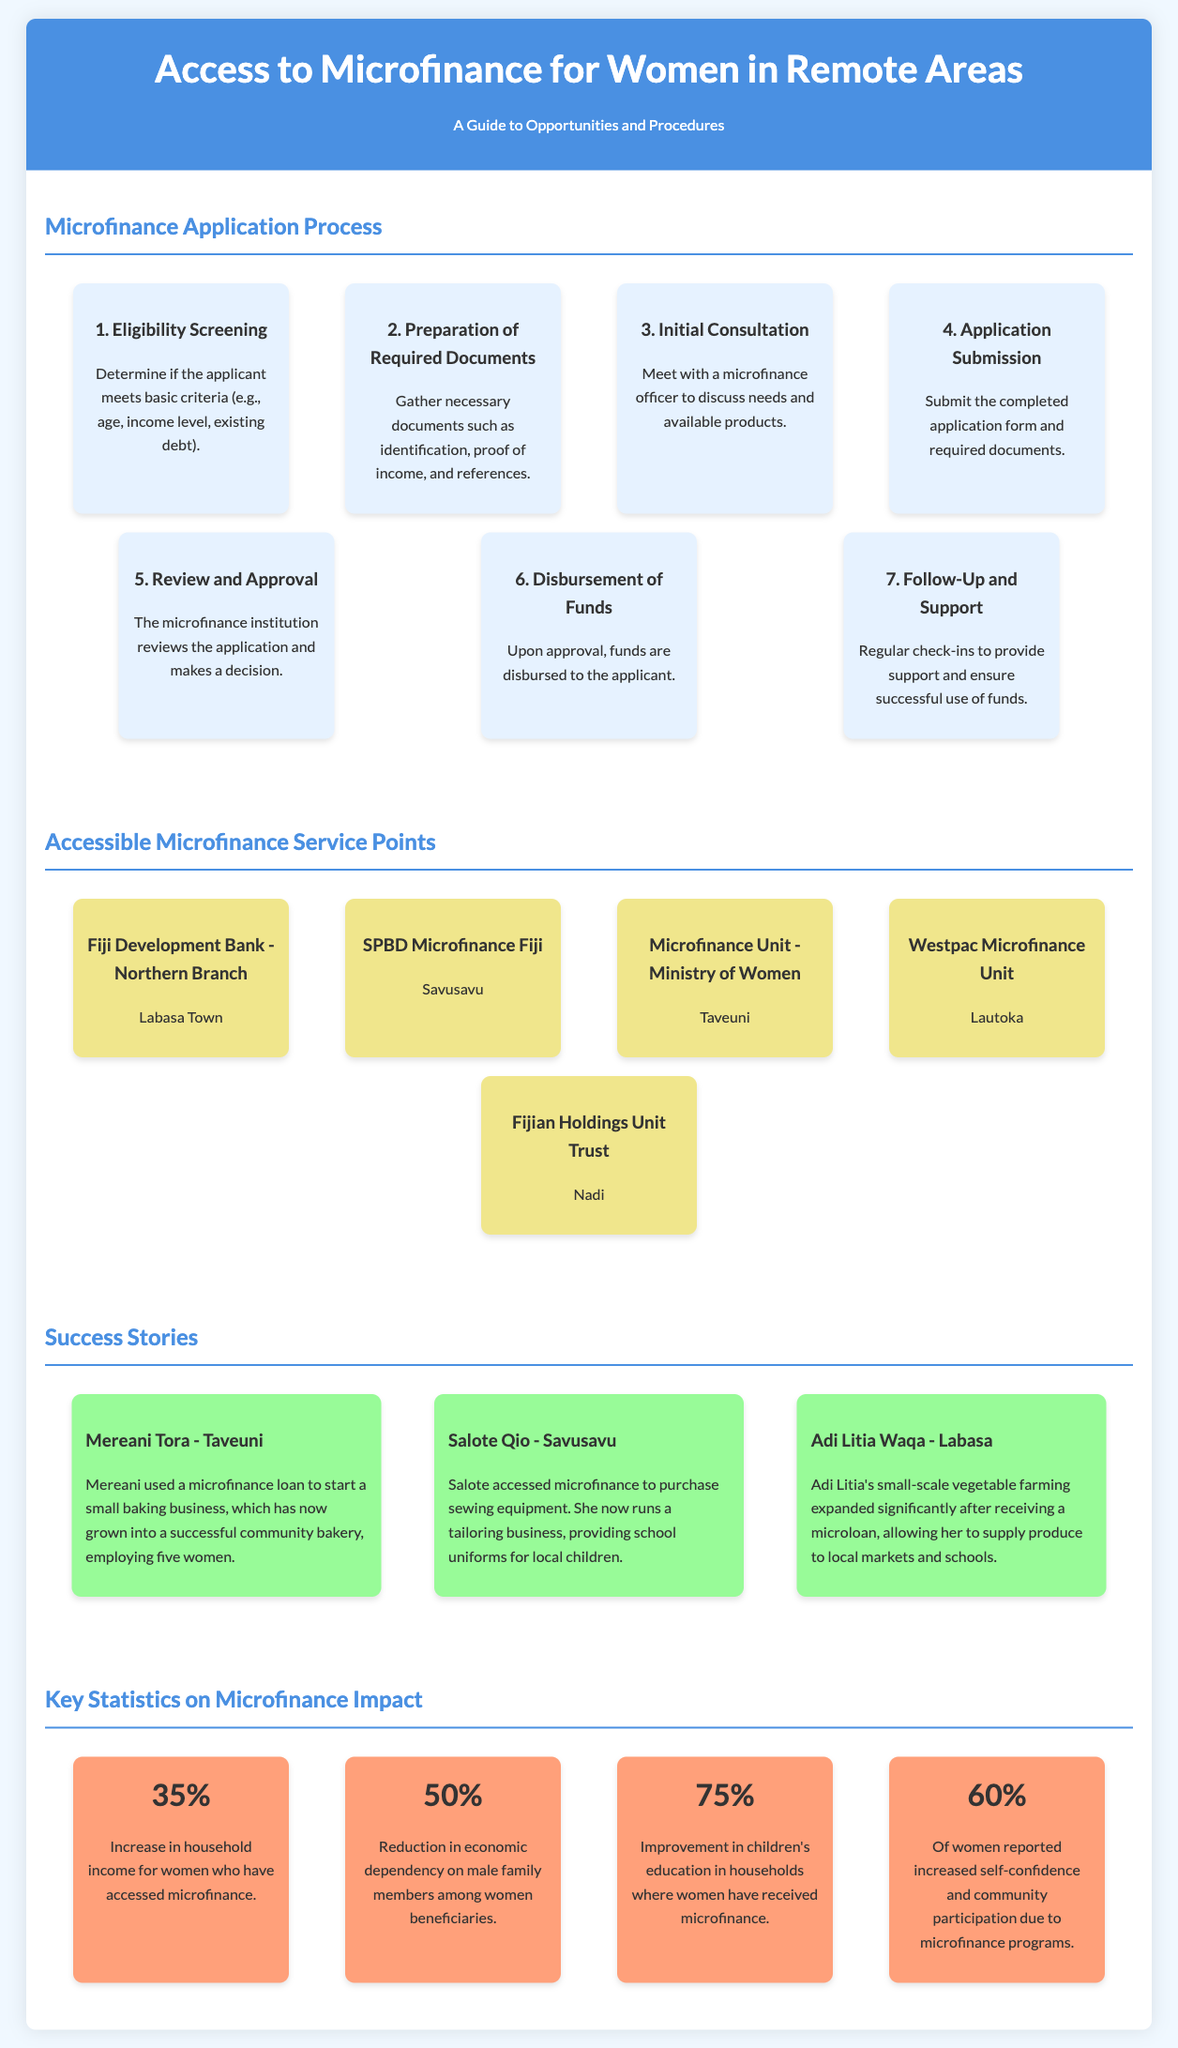What is the first step in the application process? The first step is to determine if the applicant meets basic criteria.
Answer: Eligibility Screening What is one of the required documents to gather? The documents required include identification, proof of income, and references.
Answer: Identification Where is the Fiji Development Bank located? The document states that its Northern Branch is located in Labasa Town.
Answer: Labasa Town What percentage of women experienced an increase in household income? The document indicates that 35% of women saw an increase in household income after accessing microfinance.
Answer: 35% Who is the success story from Taveuni? The success story from Taveuni is about Mereani Tora.
Answer: Mereani Tora How many service points are highlighted in the infographic? The document lists five accessible microfinance service points.
Answer: Five What major product does Salote Qio provide? The document explains that Salote Qio runs a tailoring business for school uniforms.
Answer: School uniforms What is the improvement percentage in children's education due to microfinance? The infographic shows that there is a 75% improvement in children's education in such households.
Answer: 75% What is the color theme for the flowchart steps? The flowchart steps have a background color of light blue (#e6f2ff).
Answer: Light blue 